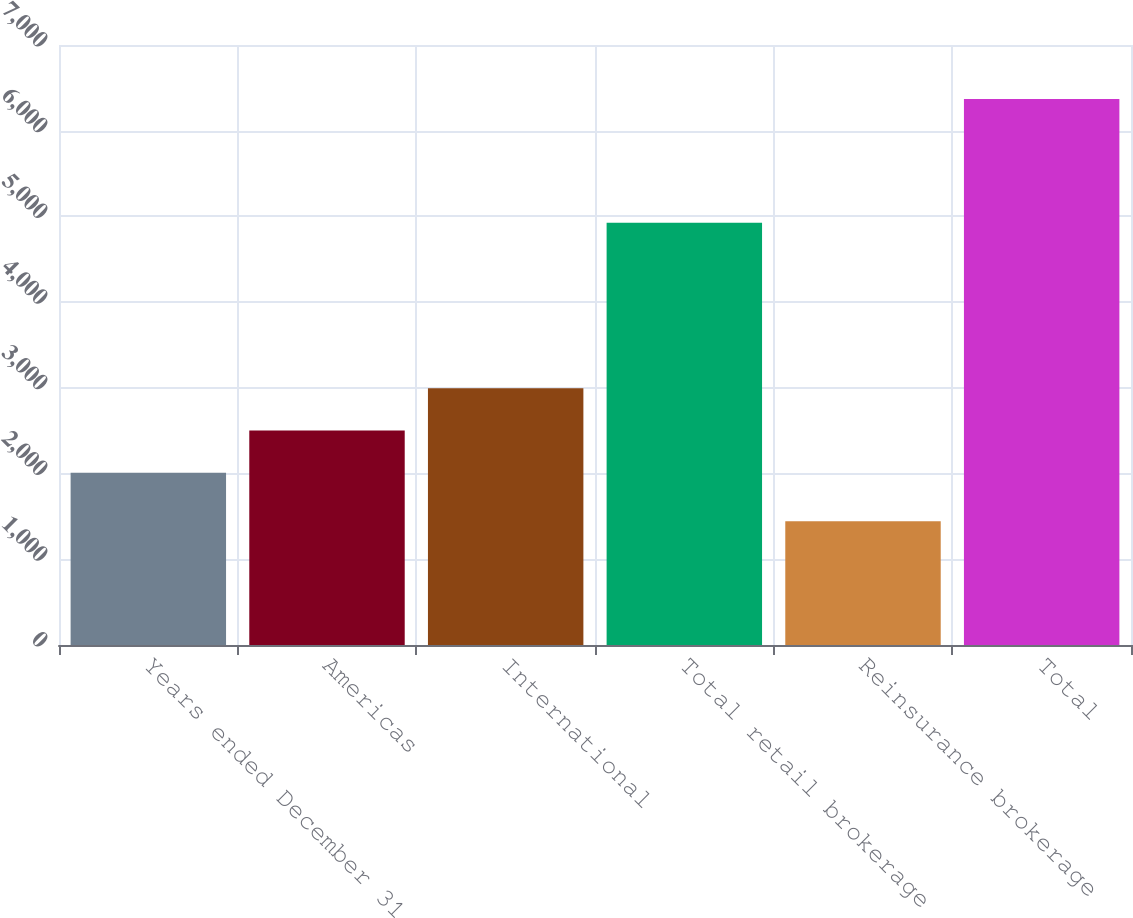Convert chart. <chart><loc_0><loc_0><loc_500><loc_500><bar_chart><fcel>Years ended December 31<fcel>Americas<fcel>International<fcel>Total retail brokerage<fcel>Reinsurance brokerage<fcel>Total<nl><fcel>2010<fcel>2502.5<fcel>2995<fcel>4925<fcel>1444<fcel>6369<nl></chart> 